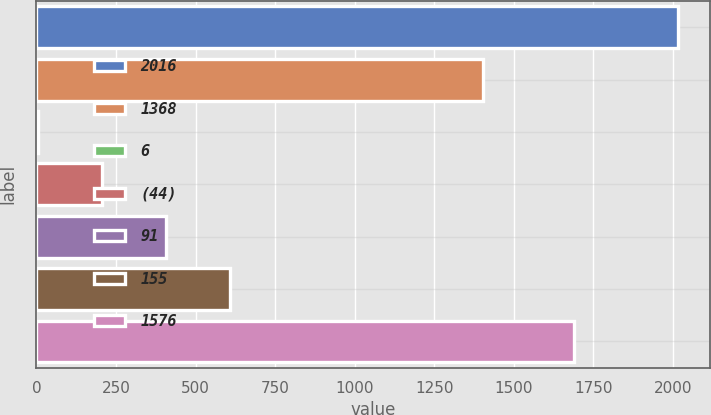<chart> <loc_0><loc_0><loc_500><loc_500><bar_chart><fcel>2016<fcel>1368<fcel>6<fcel>(44)<fcel>91<fcel>155<fcel>1576<nl><fcel>2015<fcel>1403<fcel>4<fcel>205.1<fcel>406.2<fcel>607.3<fcel>1688<nl></chart> 